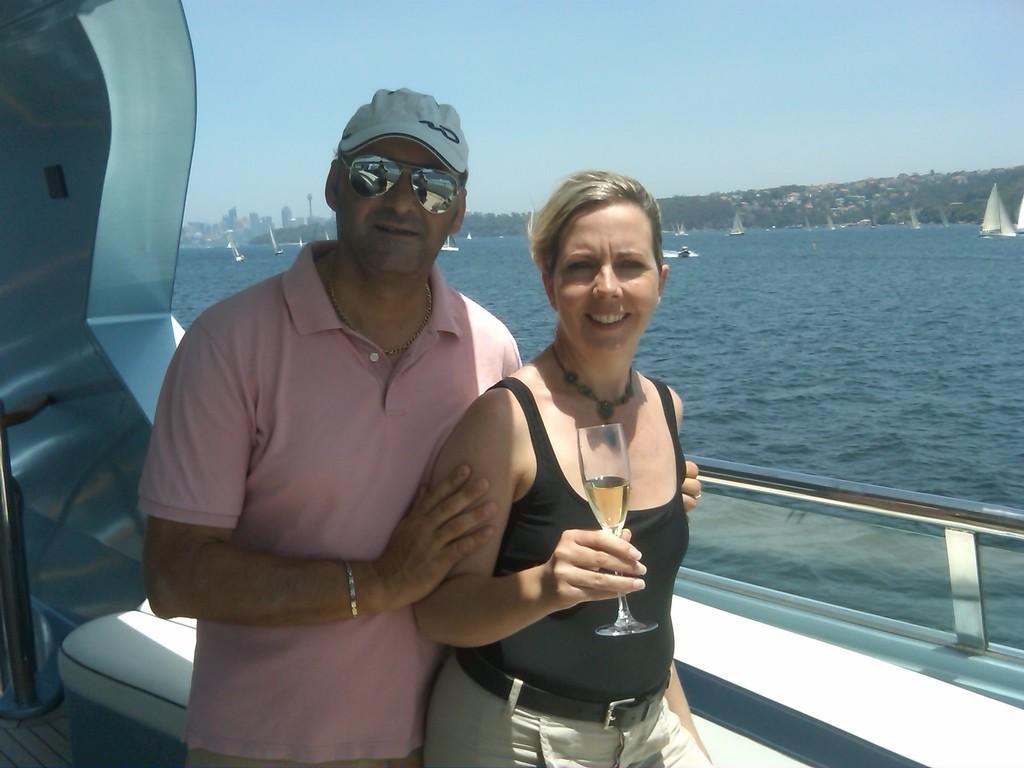In one or two sentences, can you explain what this image depicts? In the image I can see a man and a woman are standing together. The woman on the right side is holding a glass in the hand. In the background I can see boats on the water, trees, buildings and the sky. 